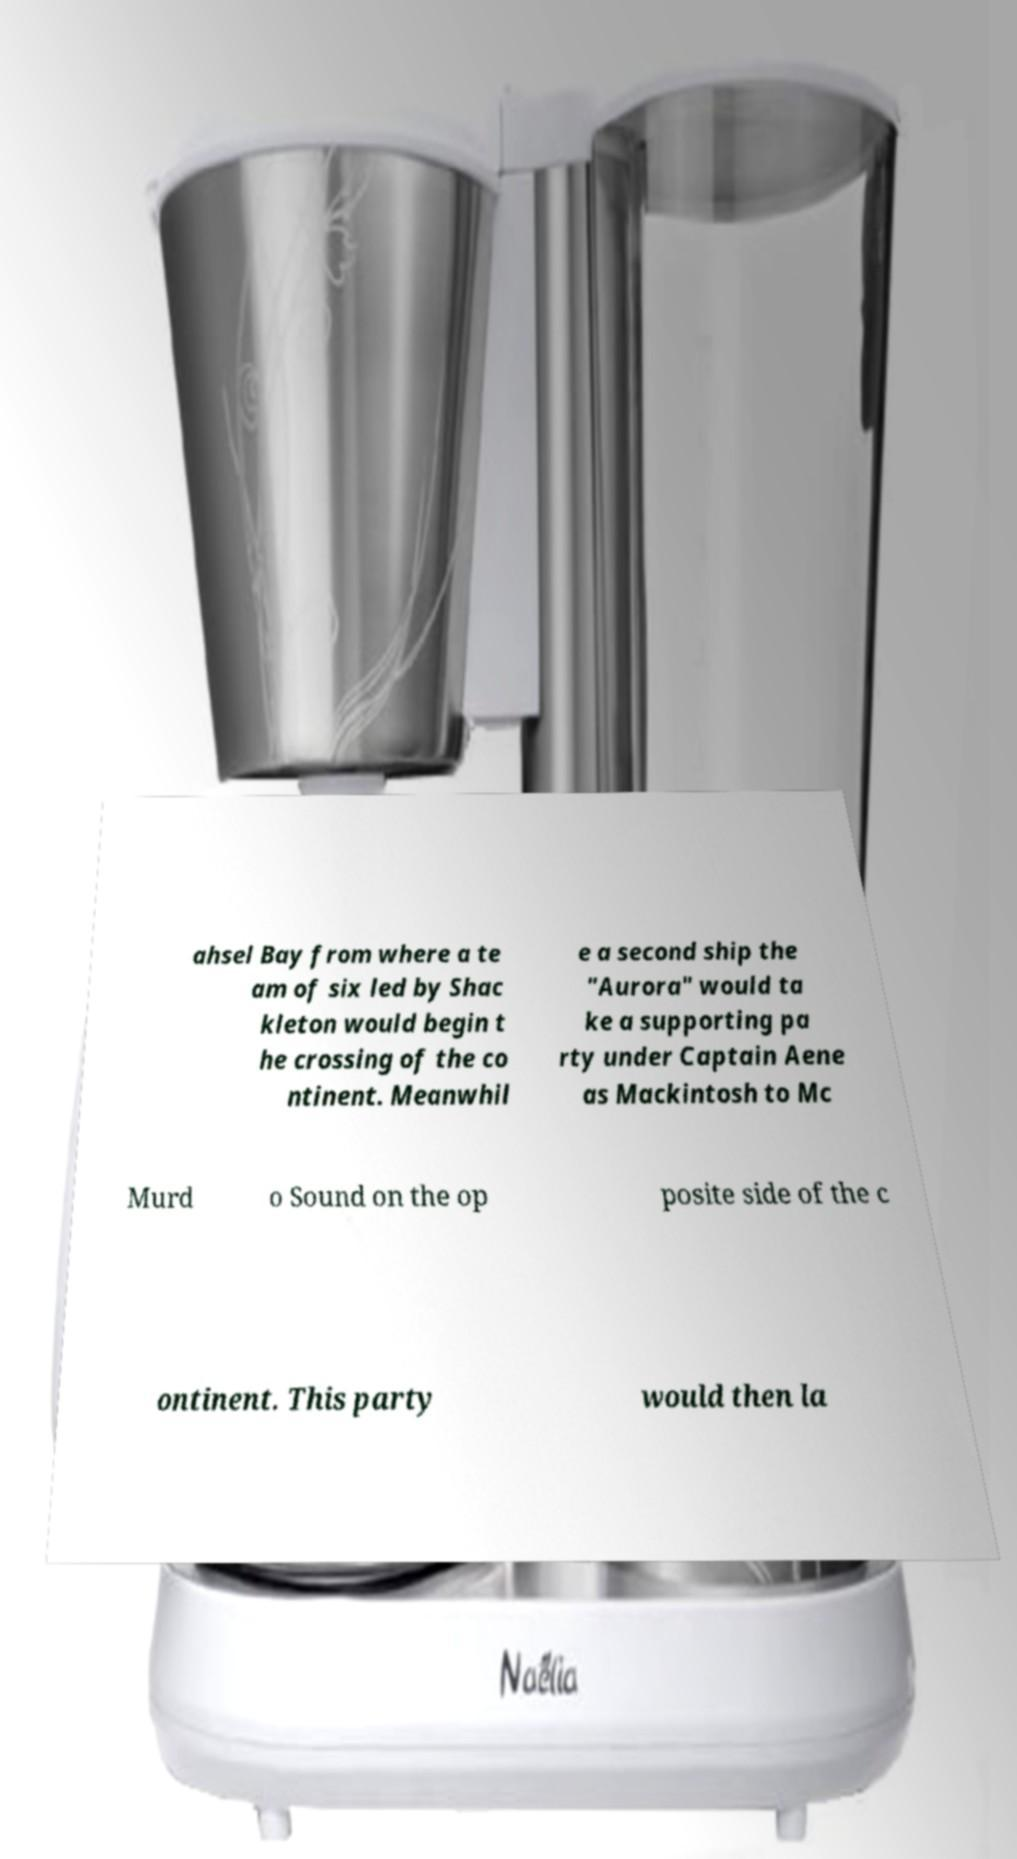Can you accurately transcribe the text from the provided image for me? ahsel Bay from where a te am of six led by Shac kleton would begin t he crossing of the co ntinent. Meanwhil e a second ship the "Aurora" would ta ke a supporting pa rty under Captain Aene as Mackintosh to Mc Murd o Sound on the op posite side of the c ontinent. This party would then la 